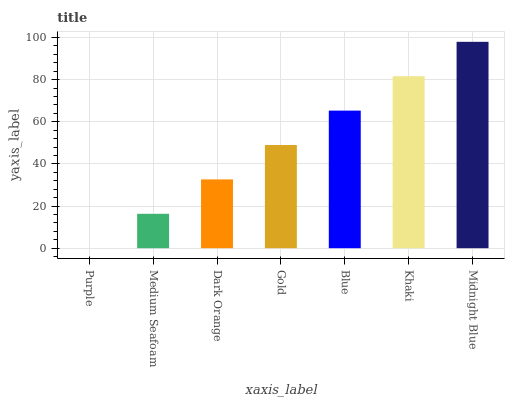Is Purple the minimum?
Answer yes or no. Yes. Is Midnight Blue the maximum?
Answer yes or no. Yes. Is Medium Seafoam the minimum?
Answer yes or no. No. Is Medium Seafoam the maximum?
Answer yes or no. No. Is Medium Seafoam greater than Purple?
Answer yes or no. Yes. Is Purple less than Medium Seafoam?
Answer yes or no. Yes. Is Purple greater than Medium Seafoam?
Answer yes or no. No. Is Medium Seafoam less than Purple?
Answer yes or no. No. Is Gold the high median?
Answer yes or no. Yes. Is Gold the low median?
Answer yes or no. Yes. Is Midnight Blue the high median?
Answer yes or no. No. Is Blue the low median?
Answer yes or no. No. 